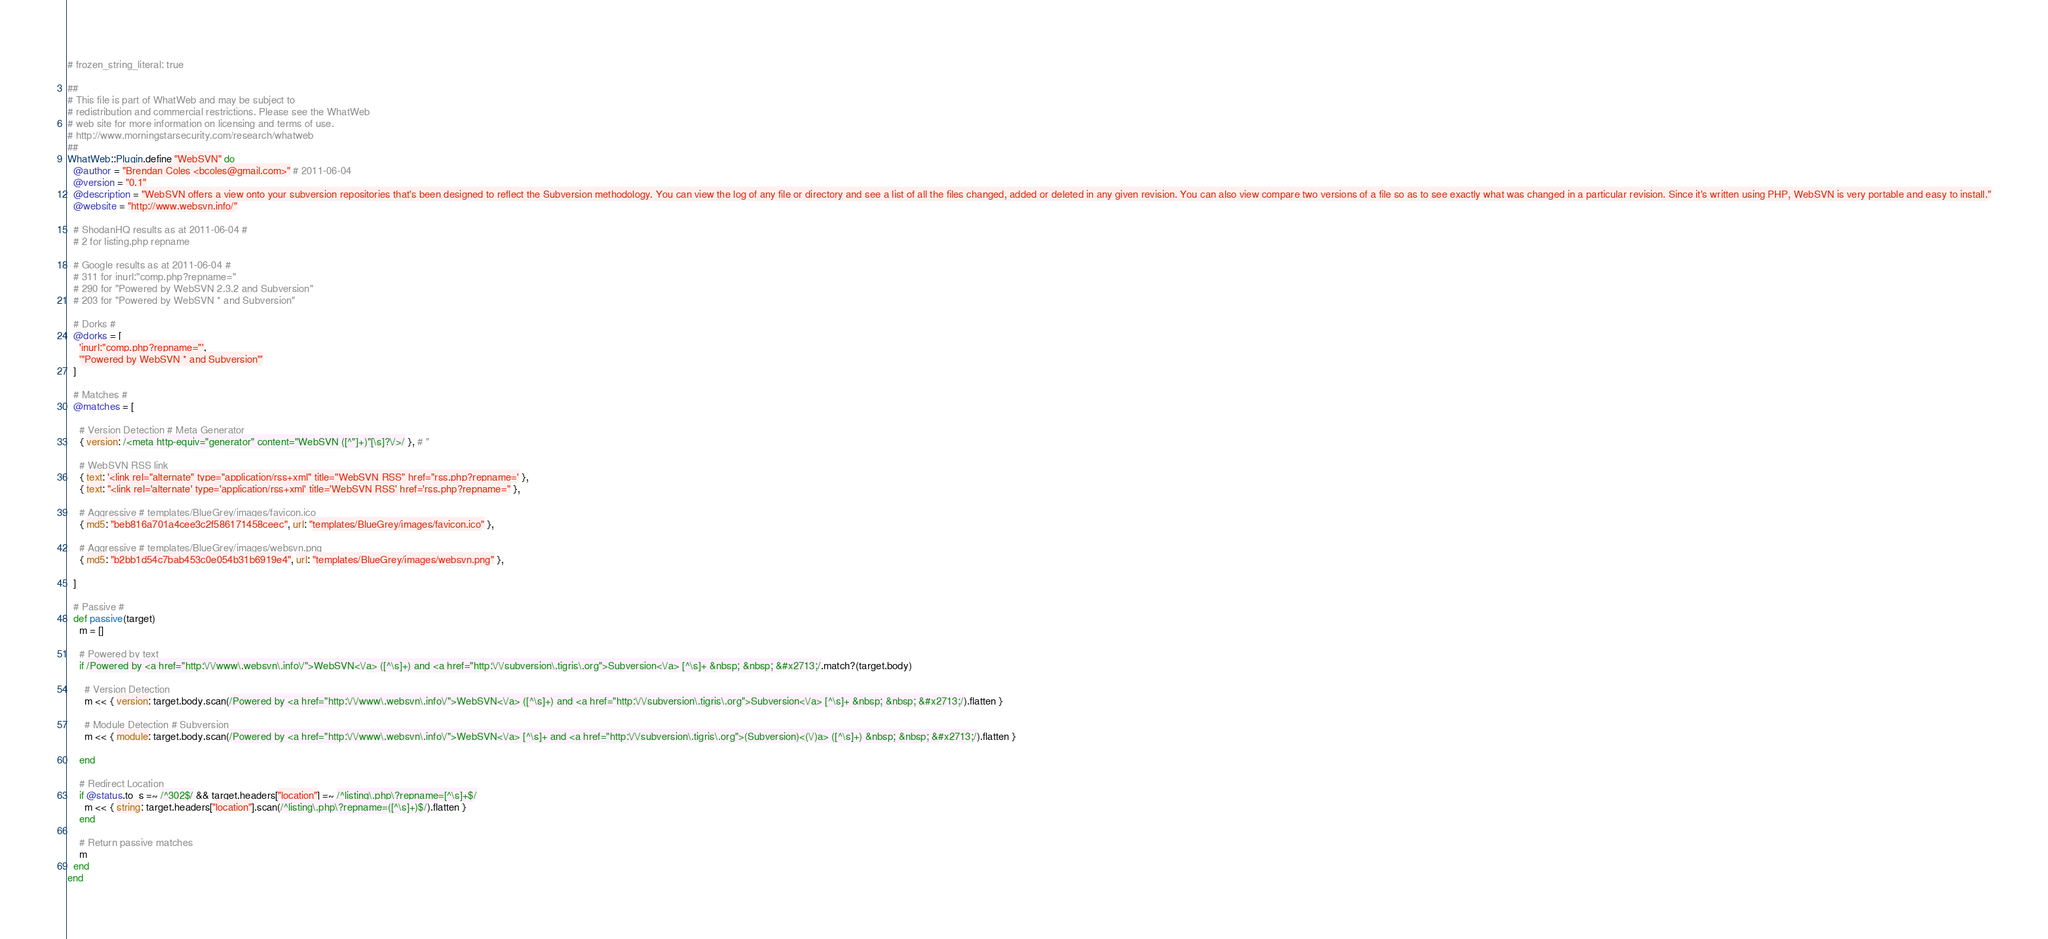Convert code to text. <code><loc_0><loc_0><loc_500><loc_500><_Ruby_># frozen_string_literal: true

##
# This file is part of WhatWeb and may be subject to
# redistribution and commercial restrictions. Please see the WhatWeb
# web site for more information on licensing and terms of use.
# http://www.morningstarsecurity.com/research/whatweb
##
WhatWeb::Plugin.define "WebSVN" do
  @author = "Brendan Coles <bcoles@gmail.com>" # 2011-06-04
  @version = "0.1"
  @description = "WebSVN offers a view onto your subversion repositories that's been designed to reflect the Subversion methodology. You can view the log of any file or directory and see a list of all the files changed, added or deleted in any given revision. You can also view compare two versions of a file so as to see exactly what was changed in a particular revision. Since it's written using PHP, WebSVN is very portable and easy to install."
  @website = "http://www.websvn.info/"

  # ShodanHQ results as at 2011-06-04 #
  # 2 for listing.php repname

  # Google results as at 2011-06-04 #
  # 311 for inurl:"comp.php?repname="
  # 290 for "Powered by WebSVN 2.3.2 and Subversion"
  # 203 for "Powered by WebSVN * and Subversion"

  # Dorks #
  @dorks = [
    'inurl:"comp.php?repname="',
    '"Powered by WebSVN * and Subversion"'
  ]

  # Matches #
  @matches = [

    # Version Detection # Meta Generator
    { version: /<meta http-equiv="generator" content="WebSVN ([^"]+)"[\s]?\/>/ }, # "

    # WebSVN RSS link
    { text: '<link rel="alternate" type="application/rss+xml" title="WebSVN RSS" href="rss.php?repname=' },
    { text: "<link rel='alternate' type='application/rss+xml' title='WebSVN RSS' href='rss.php?repname=" },

    # Aggressive # templates/BlueGrey/images/favicon.ico
    { md5: "beb816a701a4cee3c2f586171458ceec", url: "templates/BlueGrey/images/favicon.ico" },

    # Aggressive # templates/BlueGrey/images/websvn.png
    { md5: "b2bb1d54c7bab453c0e054b31b6919e4", url: "templates/BlueGrey/images/websvn.png" },

  ]

  # Passive #
  def passive(target)
    m = []

    # Powered by text
    if /Powered by <a href="http:\/\/www\.websvn\.info\/">WebSVN<\/a> ([^\s]+) and <a href="http:\/\/subversion\.tigris\.org">Subversion<\/a> [^\s]+ &nbsp; &nbsp; &#x2713;/.match?(target.body)

      # Version Detection
      m << { version: target.body.scan(/Powered by <a href="http:\/\/www\.websvn\.info\/">WebSVN<\/a> ([^\s]+) and <a href="http:\/\/subversion\.tigris\.org">Subversion<\/a> [^\s]+ &nbsp; &nbsp; &#x2713;/).flatten }

      # Module Detection # Subversion
      m << { module: target.body.scan(/Powered by <a href="http:\/\/www\.websvn\.info\/">WebSVN<\/a> [^\s]+ and <a href="http:\/\/subversion\.tigris\.org">(Subversion)<(\/)a> ([^\s]+) &nbsp; &nbsp; &#x2713;/).flatten }

    end

    # Redirect Location
    if @status.to_s =~ /^302$/ && target.headers["location"] =~ /^listing\.php\?repname=[^\s]+$/
      m << { string: target.headers["location"].scan(/^listing\.php\?repname=([^\s]+)$/).flatten }
    end

    # Return passive matches
    m
  end
end
</code> 